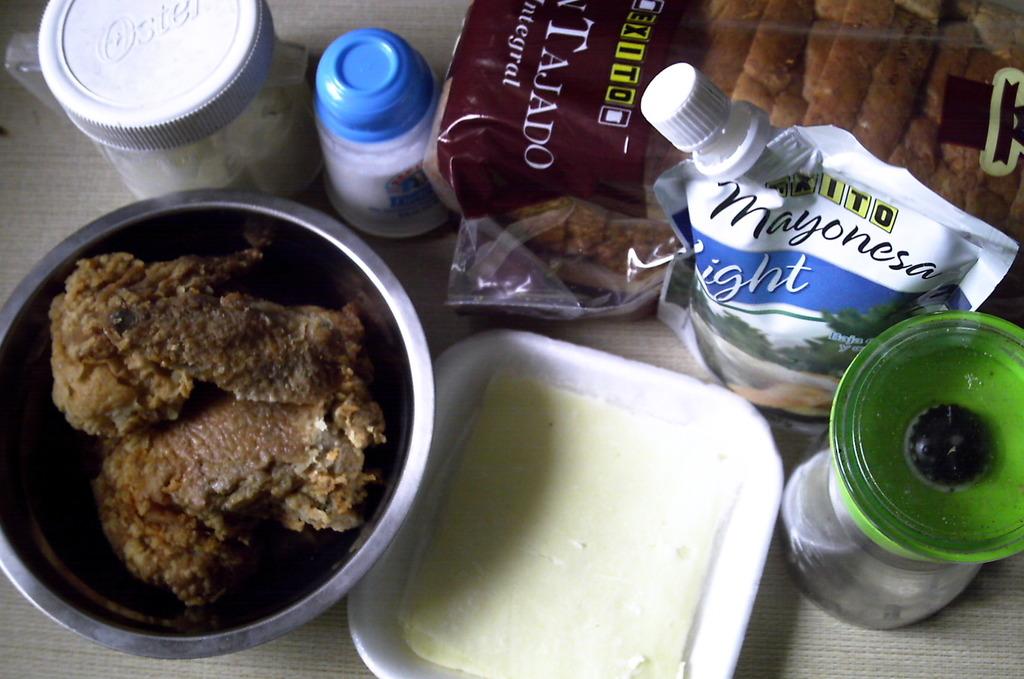What brand is the bread and mayonnaise?
Your response must be concise. Unanswerable. 